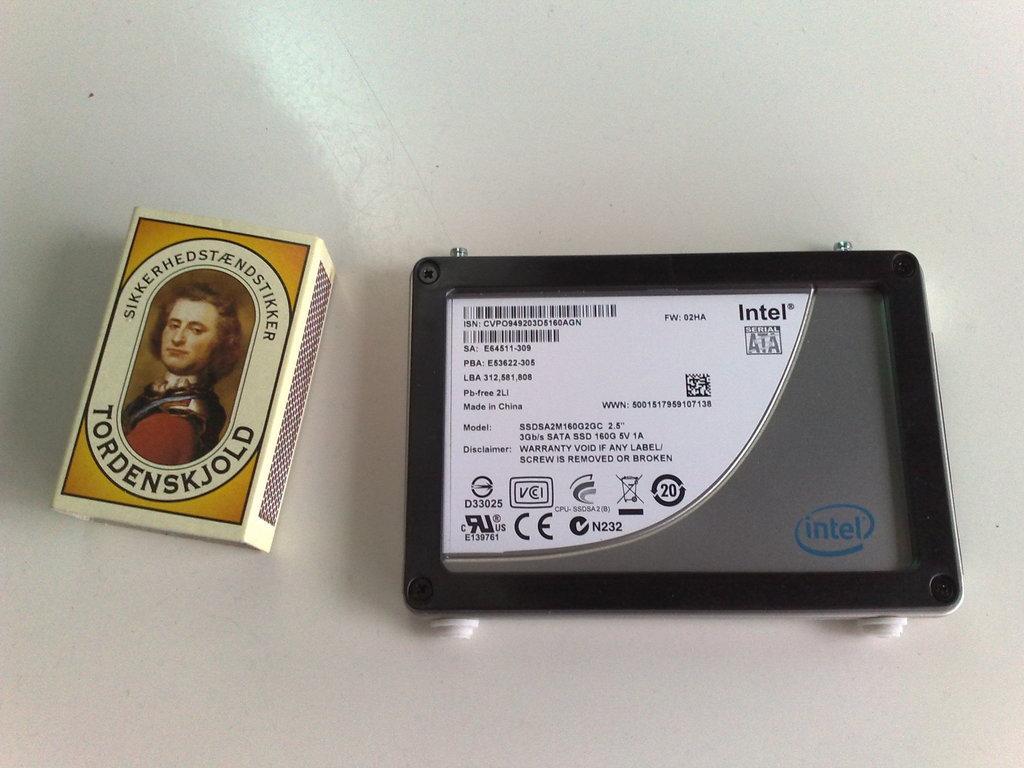Describe this image in one or two sentences. In this image there is one match box and one iPad, and there is a white background. 